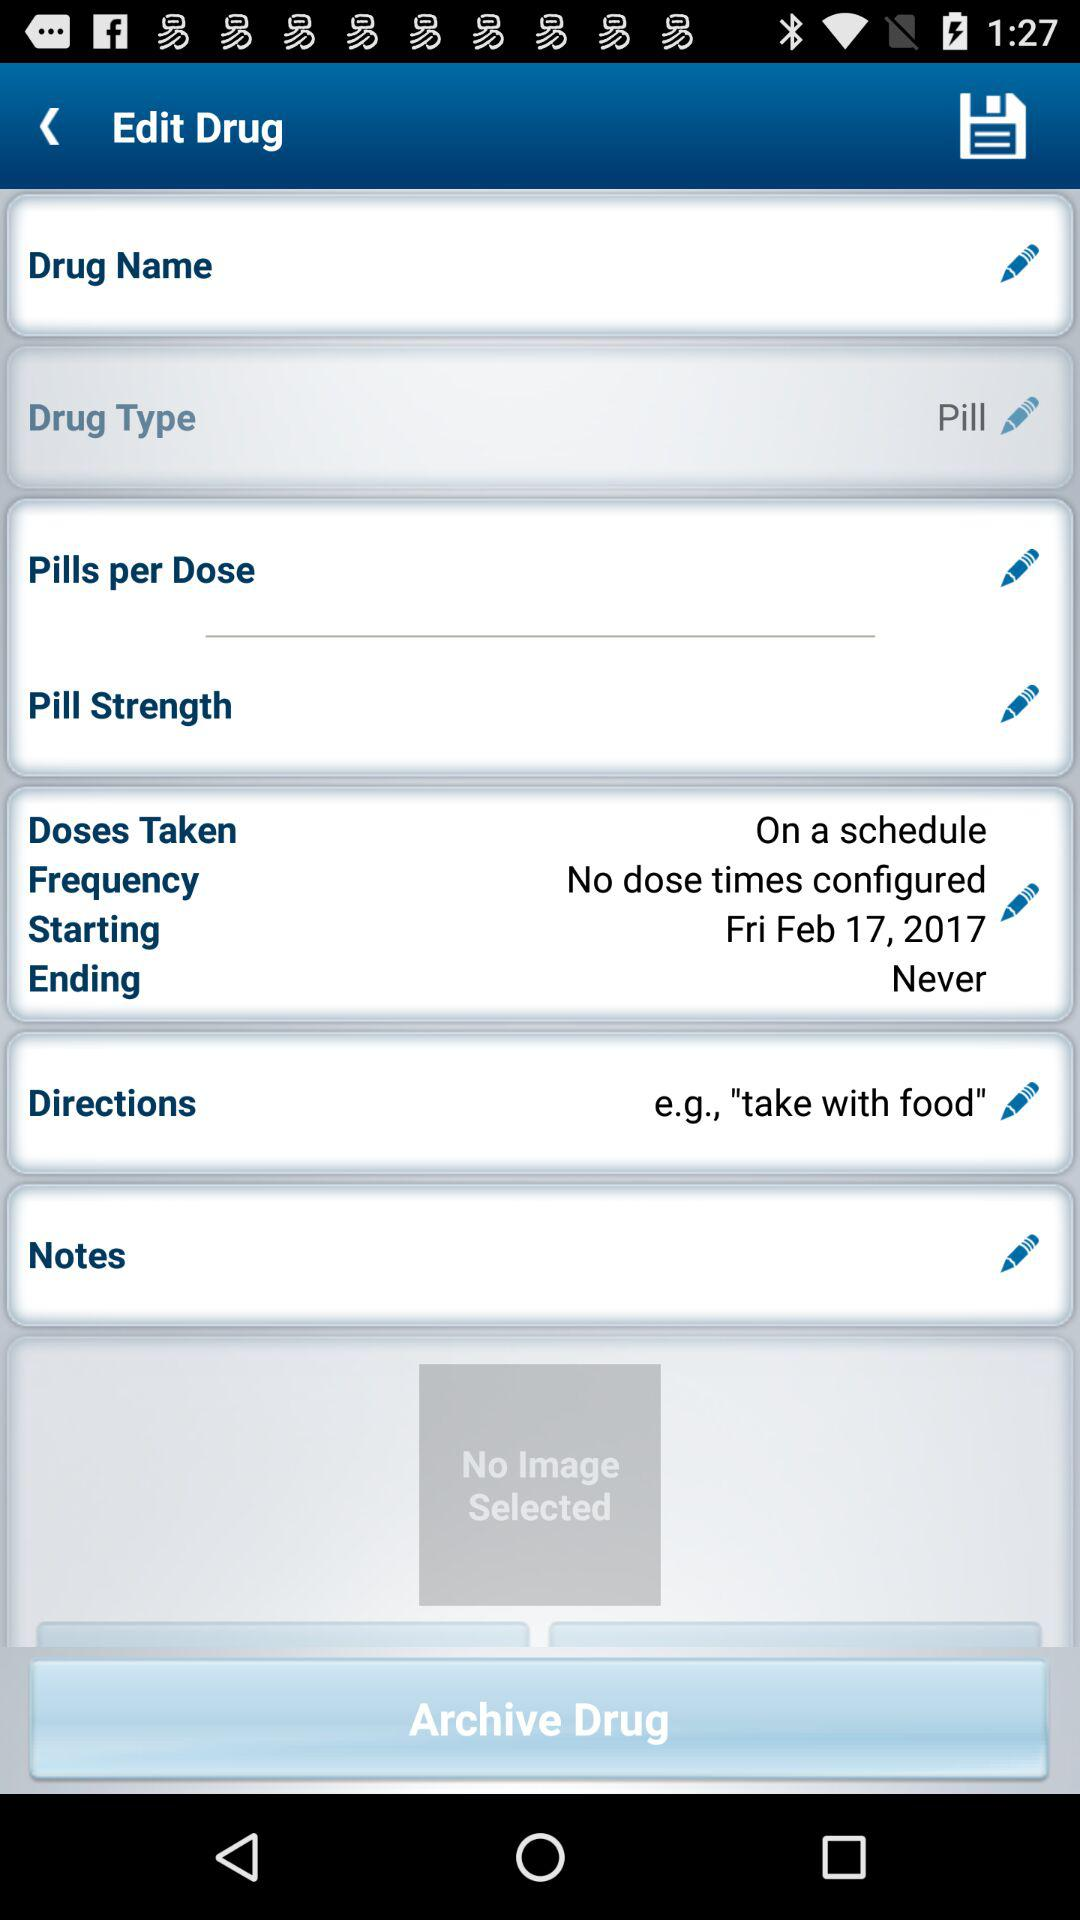What is the ending date for the dosage? The ending date for the dosage is "Never". 